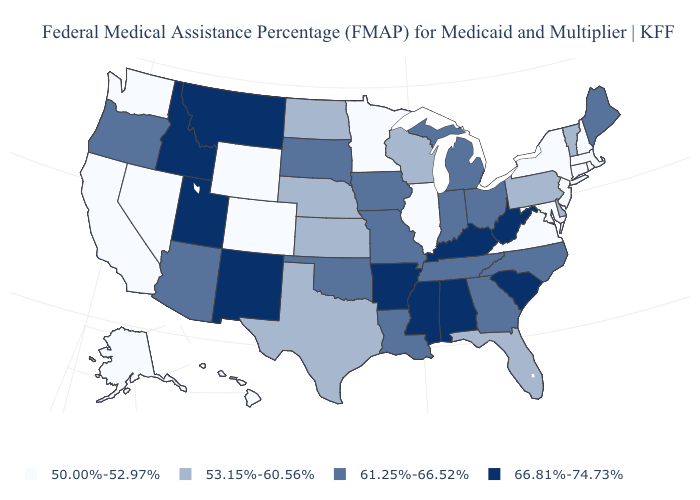Which states hav the highest value in the South?
Keep it brief. Alabama, Arkansas, Kentucky, Mississippi, South Carolina, West Virginia. What is the value of Michigan?
Write a very short answer. 61.25%-66.52%. Does Arkansas have the lowest value in the USA?
Short answer required. No. Which states have the lowest value in the West?
Short answer required. Alaska, California, Colorado, Hawaii, Nevada, Washington, Wyoming. Does Arkansas have the same value as Mississippi?
Be succinct. Yes. What is the lowest value in states that border Montana?
Keep it brief. 50.00%-52.97%. Among the states that border California , which have the highest value?
Write a very short answer. Arizona, Oregon. What is the value of Washington?
Keep it brief. 50.00%-52.97%. Name the states that have a value in the range 50.00%-52.97%?
Write a very short answer. Alaska, California, Colorado, Connecticut, Hawaii, Illinois, Maryland, Massachusetts, Minnesota, Nevada, New Hampshire, New Jersey, New York, Rhode Island, Virginia, Washington, Wyoming. What is the highest value in states that border Massachusetts?
Write a very short answer. 53.15%-60.56%. Which states hav the highest value in the South?
Answer briefly. Alabama, Arkansas, Kentucky, Mississippi, South Carolina, West Virginia. What is the value of Maryland?
Be succinct. 50.00%-52.97%. Among the states that border Kentucky , does Illinois have the lowest value?
Short answer required. Yes. Does North Carolina have the lowest value in the USA?
Short answer required. No. 